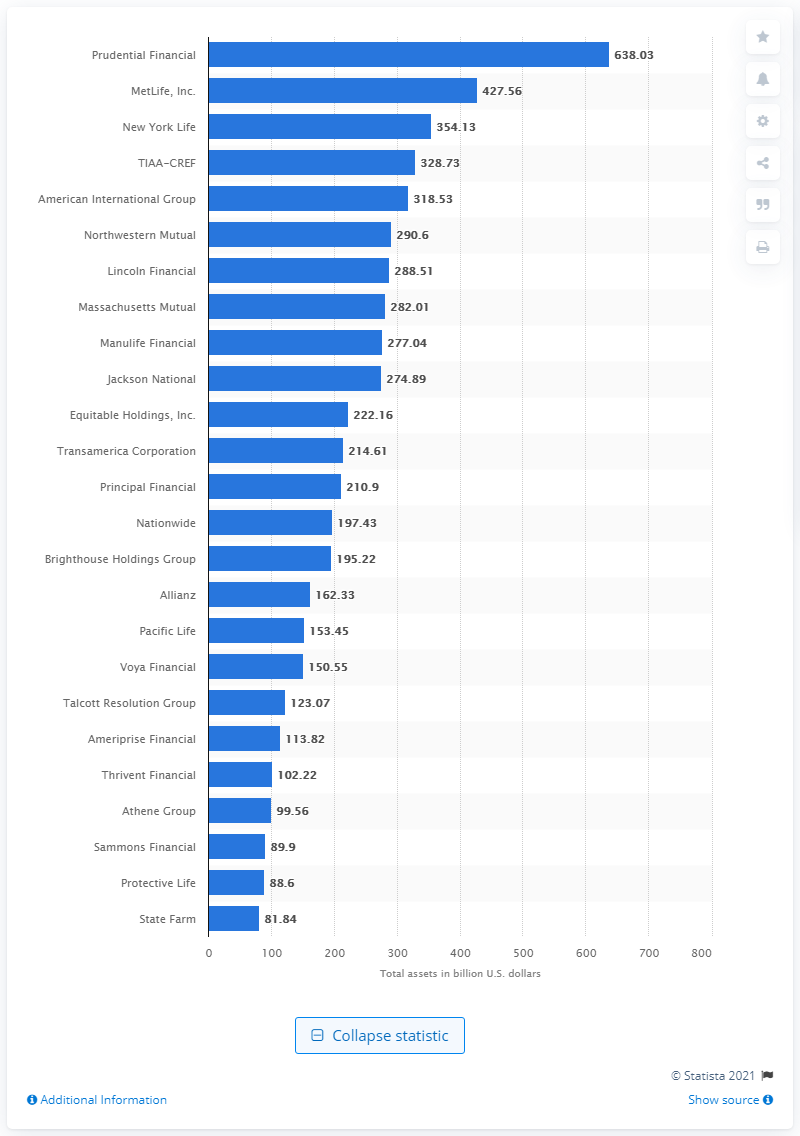Outline some significant characteristics in this image. The largest life insurance company in the United States in 2019 was Prudential Financial. In 2019, the assets of Prudential Financial were valued at approximately 638.03 dollars. 